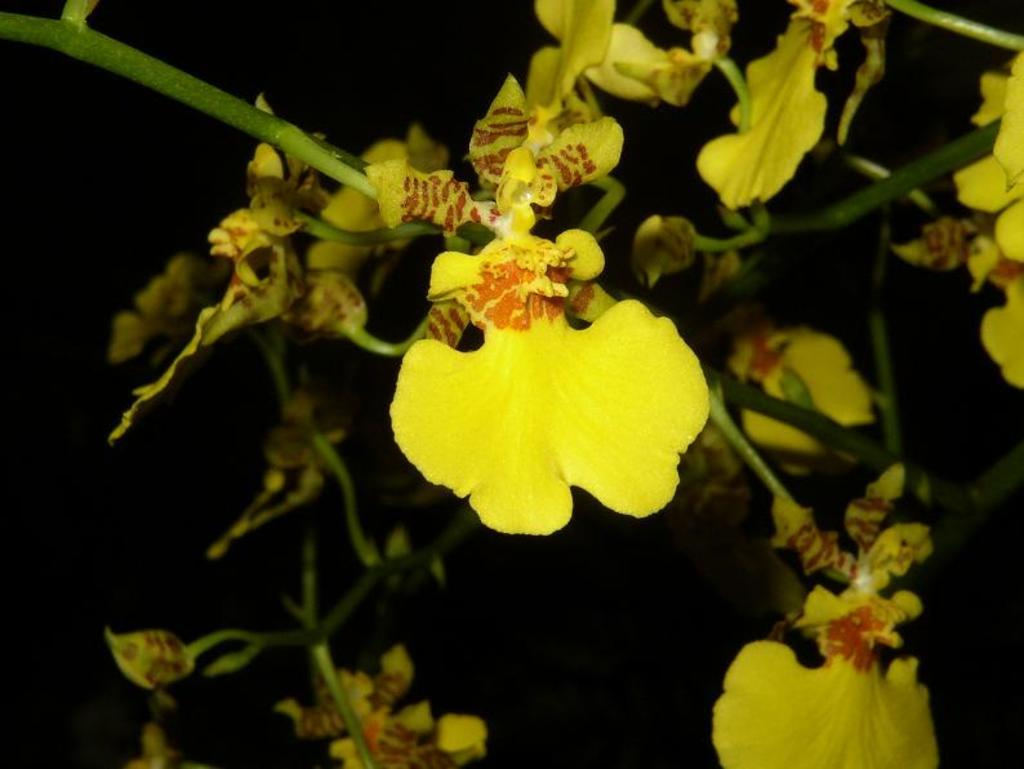What is present in the image? There is a plant in the image. What can be observed about the plant's flowers? The plant has yellow flowers. What angle is the curve of the plant's stem at in the image? There is no mention of a curve or angle in the stem of the plant in the provided facts, so it cannot be determined from the image. 